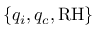<formula> <loc_0><loc_0><loc_500><loc_500>\{ q _ { i } , q _ { c } , R H \}</formula> 